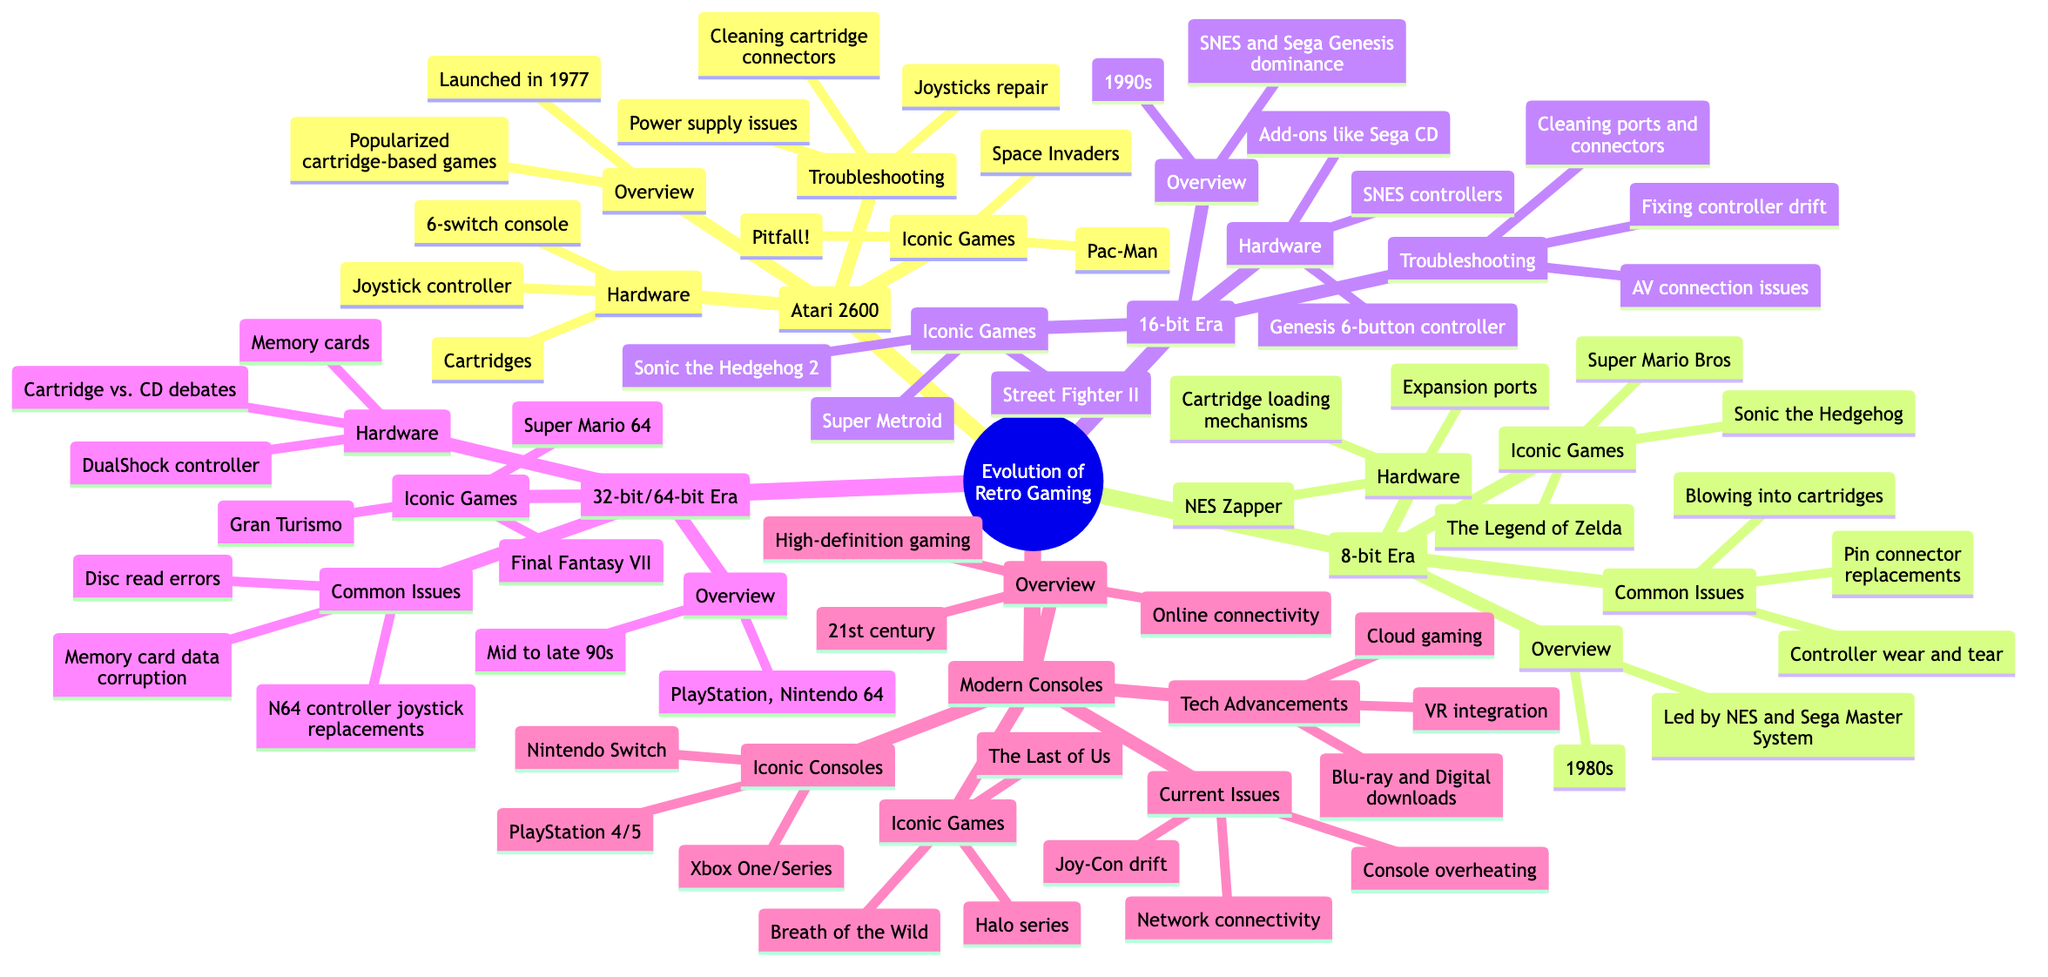What iconic game is associated with the Atari 2600? The diagram lists "Space Invaders," "Pac-Man," and "Pitfall!" under the Atari 2600 section. Any of these could serve as a correct answer but focusing on just one, "Space Invaders" is a commonly recognized title.
Answer: Space Invaders What year was the Atari 2600 launched? The "Overview" subsection of the Atari 2600 clearly states that it was launched in "1977."
Answer: 1977 Which console is mentioned as leading the 8-bit era? The section under "8-bit Era" specifies that it was "NES" and "Sega Master System" leading this era. Any named console could be a correct answer, but "NES" is especially notable.
Answer: NES How many iconic games are listed for the 16-bit era? There are three games listed under the "Iconic Games" of the 16-bit Era: "Street Fighter II," "Super Metroid," and "Sonic the Hedgehog 2." Thus, the count is three.
Answer: Three What is a common issue mentioned for the modern consoles? The section for "Current Issues" under "Modern Consoles" lists "Network connectivity," "Console overheating," and "Joy-Con drift." Selecting "Network connectivity" as one of the issues provides a satisfactory answer.
Answer: Network connectivity What type of controller was introduced with the 32-bit/64-bit era? Under the "Hardware" section for "32-bit/64-bit Era," the "DualShock controller" is mentioned, which is known for its introduction during this time.
Answer: DualShock controller What technological advancement is noted for modern consoles? The "Technological Advancements" section mentions "Blu-ray and Digital downloads," "VR integration," and "Cloud gaming." Selecting "Blu-ray" as the notable advancement succinctly answers the question.
Answer: Blu-ray Which game is highlighted under the iconic games for the 8-bit era? The "Iconic Games" section of the "8-bit Era" lists "Super Mario Bros," "The Legend of Zelda," and "Sonic the Hedgehog." "Super Mario Bros" is a widely recognized title from this era.
Answer: Super Mario Bros What type of gaming is characterized by the 21st century? The "Overview" section for "Modern Consoles" states "High-definition gaming" as part of the defining features of this period.
Answer: High-definition gaming 